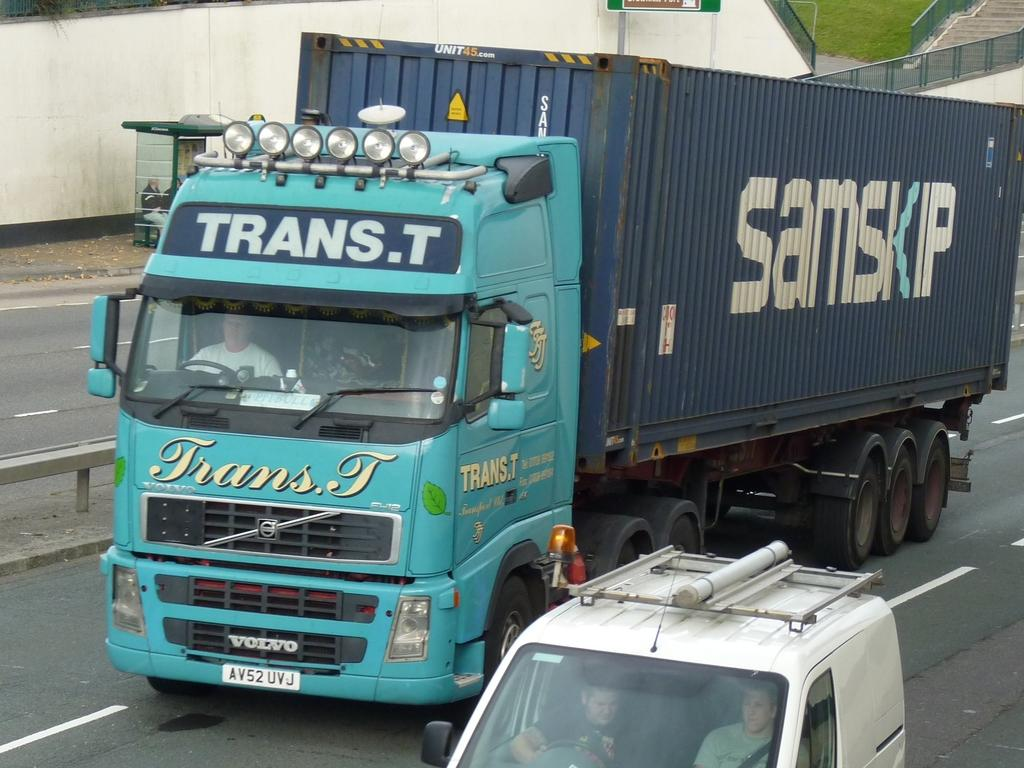What type of vehicle is on the road in the image? There is a big truck on the road in the image. Who is driving the truck? A man is driving the truck. What other vehicle is present in the image? There is a car beside the truck. Who is driving the car? A man is driving the car. What structure is opposite to the road? There is a booth opposite to the road. Who is sitting on the booth? A man is sitting on the booth. Can you see a giraffe walking on the road in the image? No, there is no giraffe present in the image. What place is depicted in the image? The image does not depict a specific place; it shows a road with vehicles and a booth. 